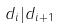<formula> <loc_0><loc_0><loc_500><loc_500>d _ { i } | d _ { i + 1 }</formula> 